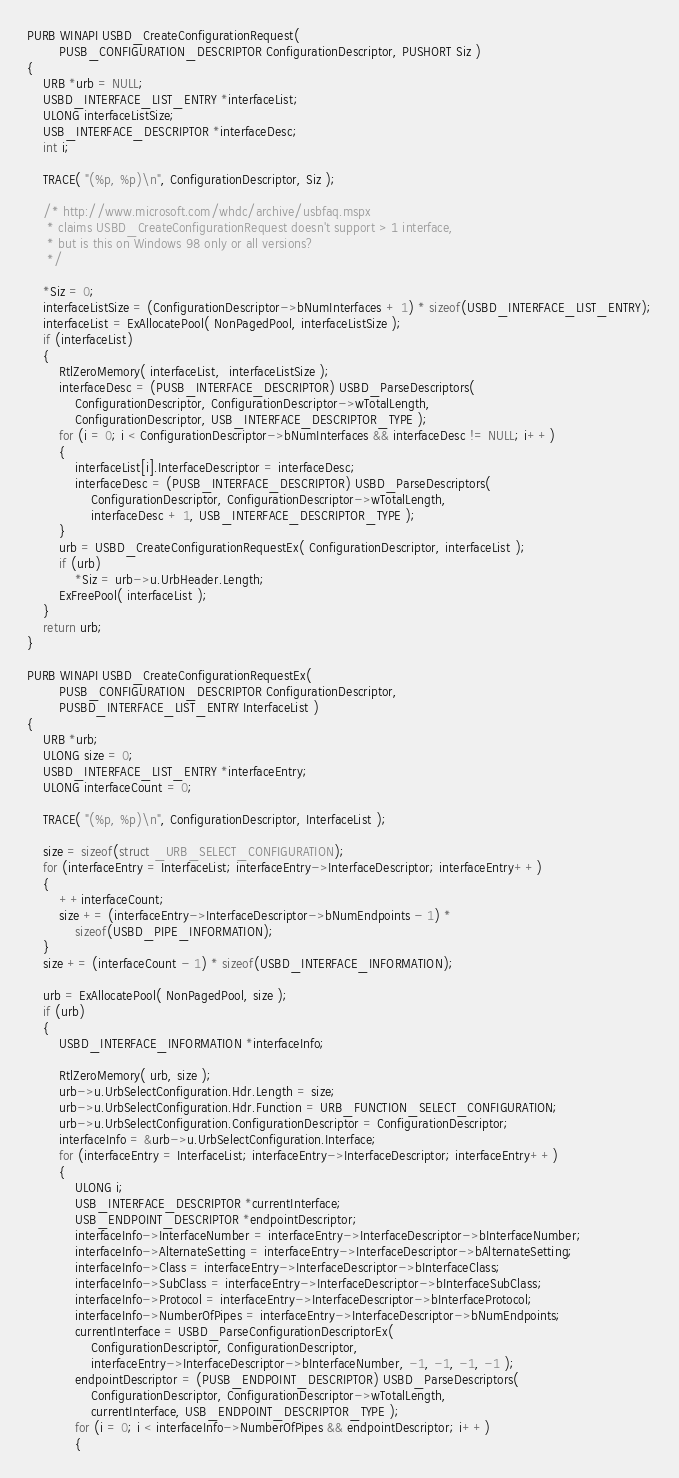<code> <loc_0><loc_0><loc_500><loc_500><_C_>
PURB WINAPI USBD_CreateConfigurationRequest(
        PUSB_CONFIGURATION_DESCRIPTOR ConfigurationDescriptor, PUSHORT Siz )
{
    URB *urb = NULL;
    USBD_INTERFACE_LIST_ENTRY *interfaceList;
    ULONG interfaceListSize;
    USB_INTERFACE_DESCRIPTOR *interfaceDesc;
    int i;

    TRACE( "(%p, %p)\n", ConfigurationDescriptor, Siz );

    /* http://www.microsoft.com/whdc/archive/usbfaq.mspx
     * claims USBD_CreateConfigurationRequest doesn't support > 1 interface,
     * but is this on Windows 98 only or all versions?
     */

    *Siz = 0;
    interfaceListSize = (ConfigurationDescriptor->bNumInterfaces + 1) * sizeof(USBD_INTERFACE_LIST_ENTRY);
    interfaceList = ExAllocatePool( NonPagedPool, interfaceListSize );
    if (interfaceList)
    {
        RtlZeroMemory( interfaceList,  interfaceListSize );
        interfaceDesc = (PUSB_INTERFACE_DESCRIPTOR) USBD_ParseDescriptors(
            ConfigurationDescriptor, ConfigurationDescriptor->wTotalLength,
            ConfigurationDescriptor, USB_INTERFACE_DESCRIPTOR_TYPE );
        for (i = 0; i < ConfigurationDescriptor->bNumInterfaces && interfaceDesc != NULL; i++)
        {
            interfaceList[i].InterfaceDescriptor = interfaceDesc;
            interfaceDesc = (PUSB_INTERFACE_DESCRIPTOR) USBD_ParseDescriptors(
                ConfigurationDescriptor, ConfigurationDescriptor->wTotalLength,
                interfaceDesc + 1, USB_INTERFACE_DESCRIPTOR_TYPE );
        }
        urb = USBD_CreateConfigurationRequestEx( ConfigurationDescriptor, interfaceList );
        if (urb)
            *Siz = urb->u.UrbHeader.Length;
        ExFreePool( interfaceList );
    }
    return urb;
}

PURB WINAPI USBD_CreateConfigurationRequestEx(
        PUSB_CONFIGURATION_DESCRIPTOR ConfigurationDescriptor,
        PUSBD_INTERFACE_LIST_ENTRY InterfaceList )
{
    URB *urb;
    ULONG size = 0;
    USBD_INTERFACE_LIST_ENTRY *interfaceEntry;
    ULONG interfaceCount = 0;

    TRACE( "(%p, %p)\n", ConfigurationDescriptor, InterfaceList );

    size = sizeof(struct _URB_SELECT_CONFIGURATION);
    for (interfaceEntry = InterfaceList; interfaceEntry->InterfaceDescriptor; interfaceEntry++)
    {
        ++interfaceCount;
        size += (interfaceEntry->InterfaceDescriptor->bNumEndpoints - 1) *
            sizeof(USBD_PIPE_INFORMATION);
    }
    size += (interfaceCount - 1) * sizeof(USBD_INTERFACE_INFORMATION);

    urb = ExAllocatePool( NonPagedPool, size );
    if (urb)
    {
        USBD_INTERFACE_INFORMATION *interfaceInfo;

        RtlZeroMemory( urb, size );
        urb->u.UrbSelectConfiguration.Hdr.Length = size;
        urb->u.UrbSelectConfiguration.Hdr.Function = URB_FUNCTION_SELECT_CONFIGURATION;
        urb->u.UrbSelectConfiguration.ConfigurationDescriptor = ConfigurationDescriptor;
        interfaceInfo = &urb->u.UrbSelectConfiguration.Interface;
        for (interfaceEntry = InterfaceList; interfaceEntry->InterfaceDescriptor; interfaceEntry++)
        {
            ULONG i;
            USB_INTERFACE_DESCRIPTOR *currentInterface;
            USB_ENDPOINT_DESCRIPTOR *endpointDescriptor;
            interfaceInfo->InterfaceNumber = interfaceEntry->InterfaceDescriptor->bInterfaceNumber;
            interfaceInfo->AlternateSetting = interfaceEntry->InterfaceDescriptor->bAlternateSetting;
            interfaceInfo->Class = interfaceEntry->InterfaceDescriptor->bInterfaceClass;
            interfaceInfo->SubClass = interfaceEntry->InterfaceDescriptor->bInterfaceSubClass;
            interfaceInfo->Protocol = interfaceEntry->InterfaceDescriptor->bInterfaceProtocol;
            interfaceInfo->NumberOfPipes = interfaceEntry->InterfaceDescriptor->bNumEndpoints;
            currentInterface = USBD_ParseConfigurationDescriptorEx(
                ConfigurationDescriptor, ConfigurationDescriptor,
                interfaceEntry->InterfaceDescriptor->bInterfaceNumber, -1, -1, -1, -1 );
            endpointDescriptor = (PUSB_ENDPOINT_DESCRIPTOR) USBD_ParseDescriptors(
                ConfigurationDescriptor, ConfigurationDescriptor->wTotalLength,
                currentInterface, USB_ENDPOINT_DESCRIPTOR_TYPE );
            for (i = 0; i < interfaceInfo->NumberOfPipes && endpointDescriptor; i++)
            {</code> 